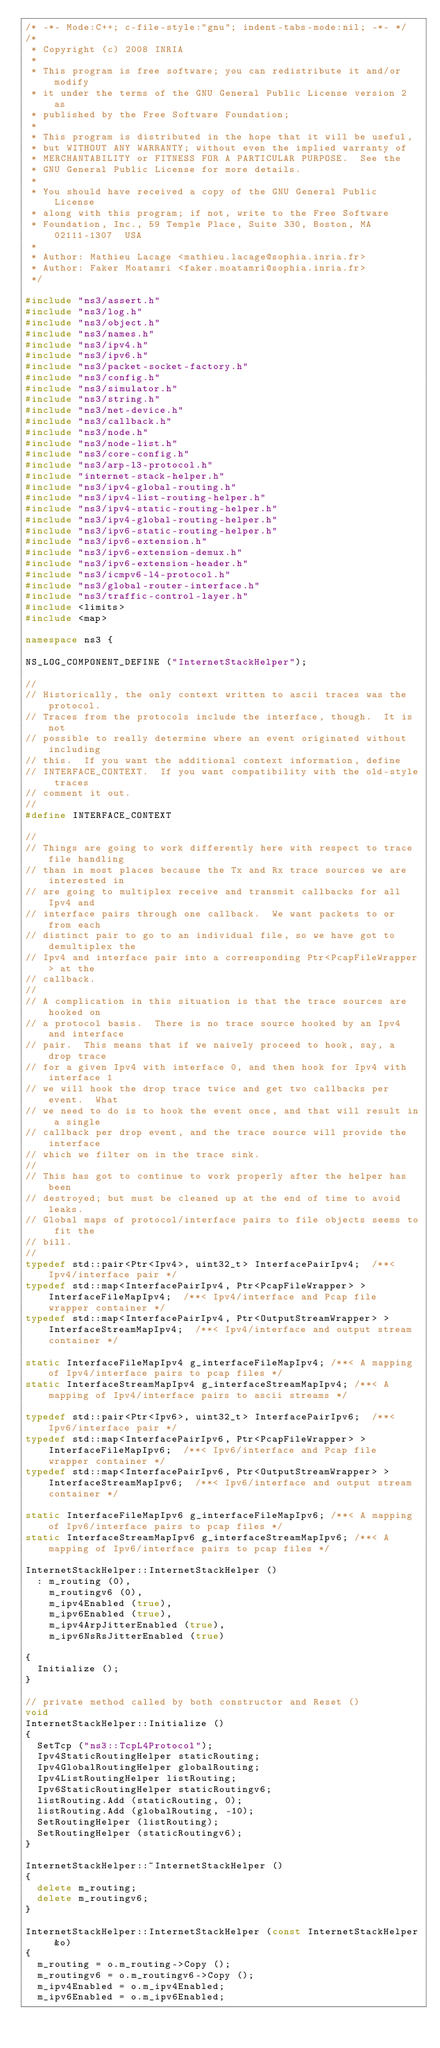Convert code to text. <code><loc_0><loc_0><loc_500><loc_500><_C++_>/* -*- Mode:C++; c-file-style:"gnu"; indent-tabs-mode:nil; -*- */
/*
 * Copyright (c) 2008 INRIA
 *
 * This program is free software; you can redistribute it and/or modify
 * it under the terms of the GNU General Public License version 2 as
 * published by the Free Software Foundation;
 *
 * This program is distributed in the hope that it will be useful,
 * but WITHOUT ANY WARRANTY; without even the implied warranty of
 * MERCHANTABILITY or FITNESS FOR A PARTICULAR PURPOSE.  See the
 * GNU General Public License for more details.
 *
 * You should have received a copy of the GNU General Public License
 * along with this program; if not, write to the Free Software
 * Foundation, Inc., 59 Temple Place, Suite 330, Boston, MA  02111-1307  USA
 *
 * Author: Mathieu Lacage <mathieu.lacage@sophia.inria.fr>
 * Author: Faker Moatamri <faker.moatamri@sophia.inria.fr>
 */

#include "ns3/assert.h"
#include "ns3/log.h"
#include "ns3/object.h"
#include "ns3/names.h"
#include "ns3/ipv4.h"
#include "ns3/ipv6.h"
#include "ns3/packet-socket-factory.h"
#include "ns3/config.h"
#include "ns3/simulator.h"
#include "ns3/string.h"
#include "ns3/net-device.h"
#include "ns3/callback.h"
#include "ns3/node.h"
#include "ns3/node-list.h"
#include "ns3/core-config.h"
#include "ns3/arp-l3-protocol.h"
#include "internet-stack-helper.h"
#include "ns3/ipv4-global-routing.h"
#include "ns3/ipv4-list-routing-helper.h"
#include "ns3/ipv4-static-routing-helper.h"
#include "ns3/ipv4-global-routing-helper.h"
#include "ns3/ipv6-static-routing-helper.h"
#include "ns3/ipv6-extension.h"
#include "ns3/ipv6-extension-demux.h"
#include "ns3/ipv6-extension-header.h"
#include "ns3/icmpv6-l4-protocol.h"
#include "ns3/global-router-interface.h"
#include "ns3/traffic-control-layer.h"
#include <limits>
#include <map>

namespace ns3 {

NS_LOG_COMPONENT_DEFINE ("InternetStackHelper");

//
// Historically, the only context written to ascii traces was the protocol.
// Traces from the protocols include the interface, though.  It is not 
// possible to really determine where an event originated without including
// this.  If you want the additional context information, define 
// INTERFACE_CONTEXT.  If you want compatibility with the old-style traces
// comment it out.
//
#define INTERFACE_CONTEXT

//
// Things are going to work differently here with respect to trace file handling
// than in most places because the Tx and Rx trace sources we are interested in
// are going to multiplex receive and transmit callbacks for all Ipv4 and 
// interface pairs through one callback.  We want packets to or from each 
// distinct pair to go to an individual file, so we have got to demultiplex the
// Ipv4 and interface pair into a corresponding Ptr<PcapFileWrapper> at the 
// callback.
//
// A complication in this situation is that the trace sources are hooked on 
// a protocol basis.  There is no trace source hooked by an Ipv4 and interface
// pair.  This means that if we naively proceed to hook, say, a drop trace
// for a given Ipv4 with interface 0, and then hook for Ipv4 with interface 1
// we will hook the drop trace twice and get two callbacks per event.  What
// we need to do is to hook the event once, and that will result in a single
// callback per drop event, and the trace source will provide the interface
// which we filter on in the trace sink.
// 
// This has got to continue to work properly after the helper has been 
// destroyed; but must be cleaned up at the end of time to avoid leaks. 
// Global maps of protocol/interface pairs to file objects seems to fit the 
// bill.
//
typedef std::pair<Ptr<Ipv4>, uint32_t> InterfacePairIpv4;  /**< Ipv4/interface pair */
typedef std::map<InterfacePairIpv4, Ptr<PcapFileWrapper> > InterfaceFileMapIpv4;  /**< Ipv4/interface and Pcap file wrapper container */
typedef std::map<InterfacePairIpv4, Ptr<OutputStreamWrapper> > InterfaceStreamMapIpv4;  /**< Ipv4/interface and output stream container */

static InterfaceFileMapIpv4 g_interfaceFileMapIpv4; /**< A mapping of Ipv4/interface pairs to pcap files */
static InterfaceStreamMapIpv4 g_interfaceStreamMapIpv4; /**< A mapping of Ipv4/interface pairs to ascii streams */

typedef std::pair<Ptr<Ipv6>, uint32_t> InterfacePairIpv6;  /**< Ipv6/interface pair */
typedef std::map<InterfacePairIpv6, Ptr<PcapFileWrapper> > InterfaceFileMapIpv6;  /**< Ipv6/interface and Pcap file wrapper container */
typedef std::map<InterfacePairIpv6, Ptr<OutputStreamWrapper> > InterfaceStreamMapIpv6;  /**< Ipv6/interface and output stream container */

static InterfaceFileMapIpv6 g_interfaceFileMapIpv6; /**< A mapping of Ipv6/interface pairs to pcap files */
static InterfaceStreamMapIpv6 g_interfaceStreamMapIpv6; /**< A mapping of Ipv6/interface pairs to pcap files */

InternetStackHelper::InternetStackHelper ()
  : m_routing (0),
    m_routingv6 (0),
    m_ipv4Enabled (true),
    m_ipv6Enabled (true),
    m_ipv4ArpJitterEnabled (true),
    m_ipv6NsRsJitterEnabled (true)

{
  Initialize ();
}

// private method called by both constructor and Reset ()
void
InternetStackHelper::Initialize ()
{
  SetTcp ("ns3::TcpL4Protocol");
  Ipv4StaticRoutingHelper staticRouting;
  Ipv4GlobalRoutingHelper globalRouting;
  Ipv4ListRoutingHelper listRouting;
  Ipv6StaticRoutingHelper staticRoutingv6;
  listRouting.Add (staticRouting, 0);
  listRouting.Add (globalRouting, -10);
  SetRoutingHelper (listRouting);
  SetRoutingHelper (staticRoutingv6);
}

InternetStackHelper::~InternetStackHelper ()
{
  delete m_routing;
  delete m_routingv6;
}

InternetStackHelper::InternetStackHelper (const InternetStackHelper &o)
{
  m_routing = o.m_routing->Copy ();
  m_routingv6 = o.m_routingv6->Copy ();
  m_ipv4Enabled = o.m_ipv4Enabled;
  m_ipv6Enabled = o.m_ipv6Enabled;</code> 